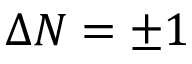<formula> <loc_0><loc_0><loc_500><loc_500>\Delta N = \pm 1</formula> 